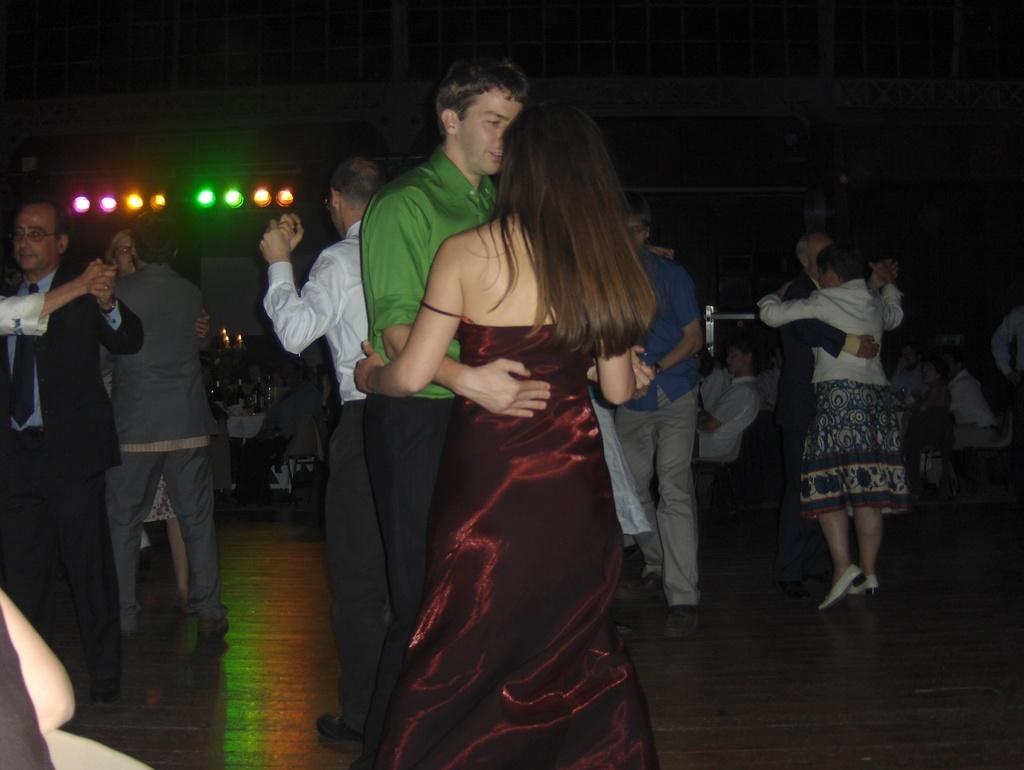What are the people in the image doing? There are couples dancing in the image. Where are the couples dancing? The couples are dancing on the floor. What can be seen in the background while the couples are dancing? There is a music system and lights visible in the background. What type of hammer is being used by the girls in the image? There are no girls or hammers present in the image; it features couples dancing. 